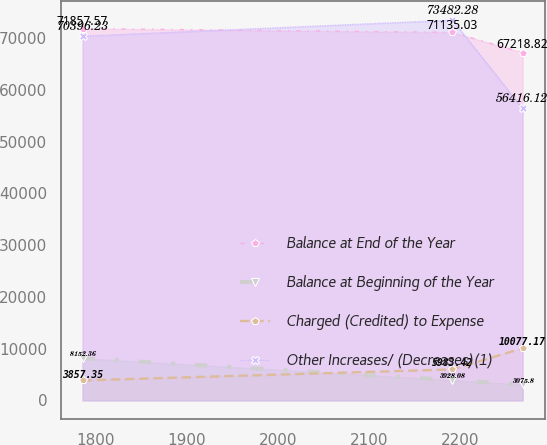Convert chart to OTSL. <chart><loc_0><loc_0><loc_500><loc_500><line_chart><ecel><fcel>Balance at End of the Year<fcel>Balance at Beginning of the Year<fcel>Charged (Credited) to Expense<fcel>Other Increases/ (Decreases)(1)<nl><fcel>1785.59<fcel>71857.6<fcel>8152.36<fcel>3857.35<fcel>70396.2<nl><fcel>2191.57<fcel>71135<fcel>3928.08<fcel>5983.42<fcel>73482.3<nl><fcel>2268.51<fcel>67218.8<fcel>3075.8<fcel>10077.2<fcel>56416.1<nl></chart> 